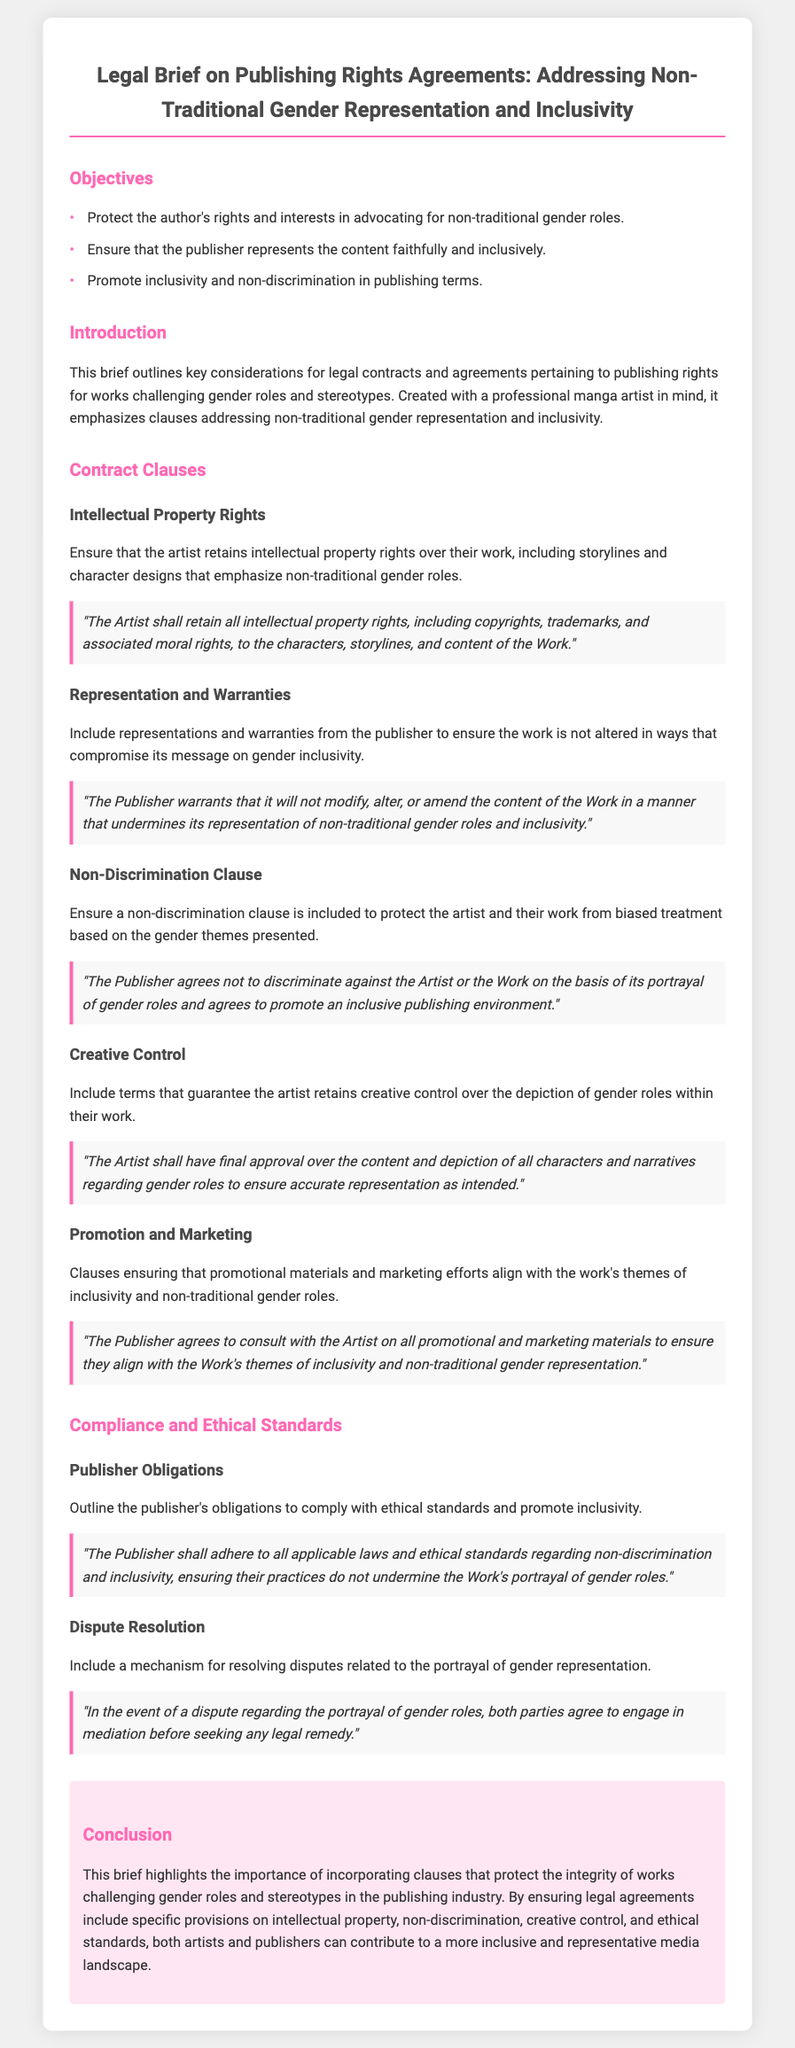What are the objectives of the legal brief? The objectives are listed in the "Objectives" section, focusing on protecting the author's rights, ensuring publisher representation, and promoting inclusivity.
Answer: Protect the author's rights and interests in advocating for non-traditional gender roles; ensure that the publisher represents the content faithfully and inclusively; promote inclusivity and non-discrimination in publishing terms What is included in the Intellectual Property Rights clause? The clause ensures that the artist retains intellectual property rights over their work, including specific elements related to gender roles.
Answer: The Artist shall retain all intellectual property rights, including copyrights, trademarks, and associated moral rights, to the characters, storylines, and content of the Work What is the purpose of the Non-Discrimination Clause? The clause protects the artist and their work from biased treatment based on the themes presented in their work.
Answer: The Publisher agrees not to discriminate against the Artist or the Work on the basis of its portrayal of gender roles and agrees to promote an inclusive publishing environment What must the Publisher guarantee in the Representation and Warranties section? The publisher must warrant that it will not compromise the work's message on gender inclusivity through modifications.
Answer: The Publisher warrants that it will not modify, alter, or amend the content of the Work in a manner that undermines its representation of non-traditional gender roles and inclusivity What type of mechanism is suggested for handling disputes? The document recommends a specific approach to resolving disputes related to the portrayal of gender representation.
Answer: In the event of a dispute regarding the portrayal of gender roles, both parties agree to engage in mediation before seeking any legal remedy 